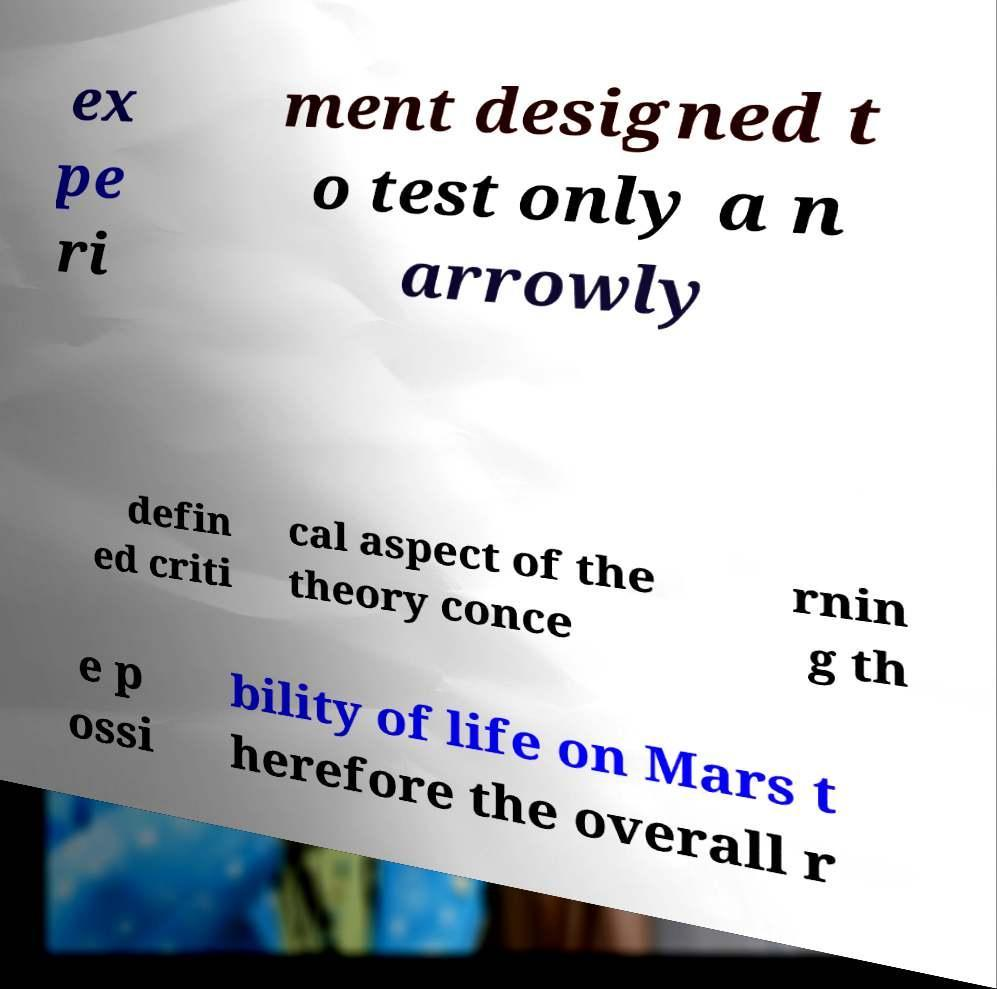Please read and relay the text visible in this image. What does it say? ex pe ri ment designed t o test only a n arrowly defin ed criti cal aspect of the theory conce rnin g th e p ossi bility of life on Mars t herefore the overall r 